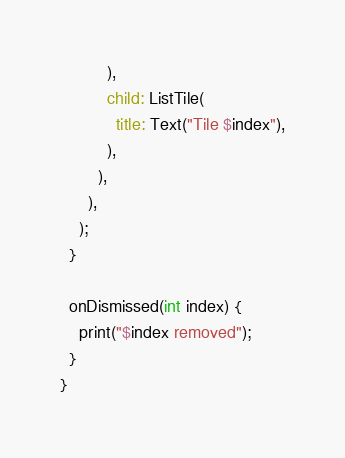<code> <loc_0><loc_0><loc_500><loc_500><_Dart_>          ),
          child: ListTile(
            title: Text("Tile $index"),
          ),
        ),
      ),
    );
  }

  onDismissed(int index) {
    print("$index removed");
  }
}
</code> 